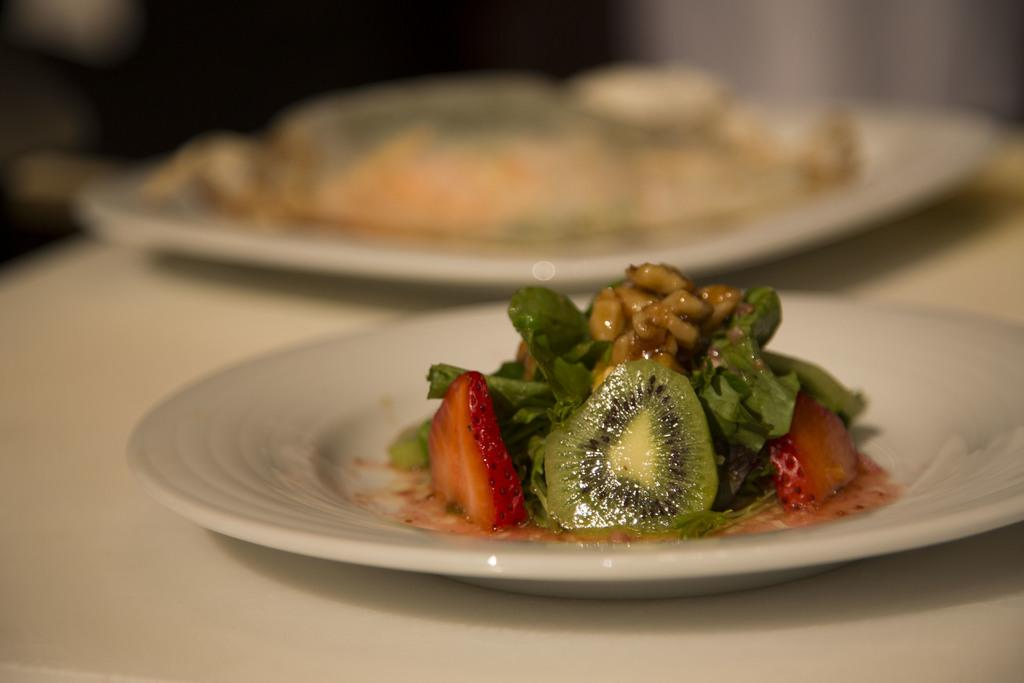What piece of furniture is present in the image? There is a table in the image. What color are the plates on the table? The plates on the table are white. What is on top of the plates? There are dishes on the plates. Can you describe the background of the image? The background of the image is blurred. Where is the basket located in the image? There is no basket present in the image. What type of floor can be seen in the image? The floor is not visible in the image, as the focus is on the table and its contents. 